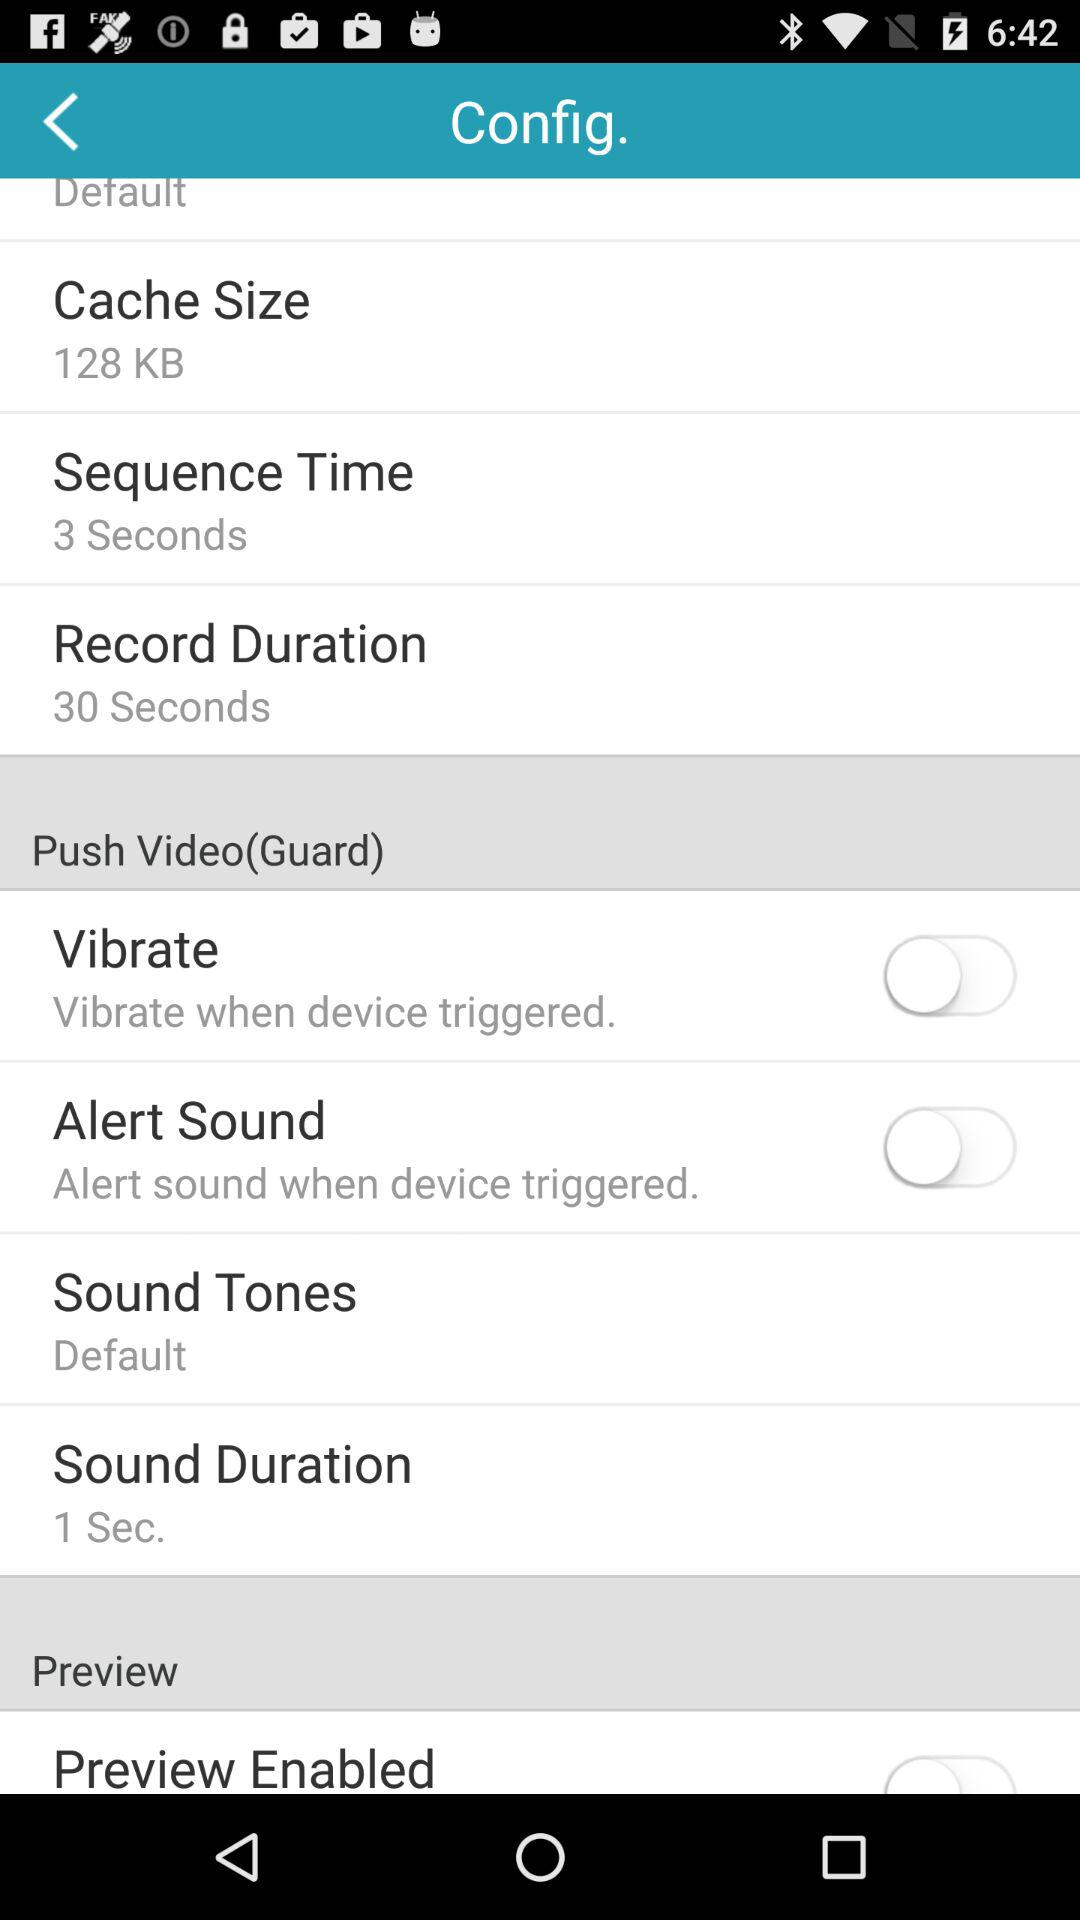What is the cache size? The cache size is 128 kb. 